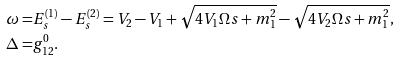Convert formula to latex. <formula><loc_0><loc_0><loc_500><loc_500>\omega = & E _ { s } ^ { ( 1 ) } - E _ { s } ^ { ( 2 ) } = V _ { 2 } - V _ { 1 } + \sqrt { 4 V _ { 1 } \Omega s + m _ { 1 } ^ { 2 } } - \sqrt { 4 V _ { 2 } \Omega s + m _ { 1 } ^ { 2 } } , \\ \Delta = & g ^ { 0 } _ { 1 2 } .</formula> 